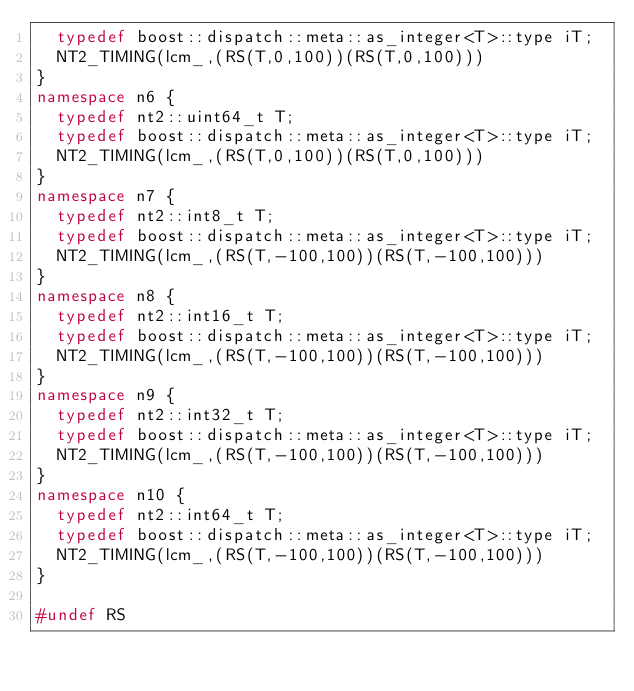<code> <loc_0><loc_0><loc_500><loc_500><_C++_>  typedef boost::dispatch::meta::as_integer<T>::type iT;
  NT2_TIMING(lcm_,(RS(T,0,100))(RS(T,0,100)))
}
namespace n6 {
  typedef nt2::uint64_t T;
  typedef boost::dispatch::meta::as_integer<T>::type iT;
  NT2_TIMING(lcm_,(RS(T,0,100))(RS(T,0,100)))
}
namespace n7 {
  typedef nt2::int8_t T;
  typedef boost::dispatch::meta::as_integer<T>::type iT;
  NT2_TIMING(lcm_,(RS(T,-100,100))(RS(T,-100,100)))
}
namespace n8 {
  typedef nt2::int16_t T;
  typedef boost::dispatch::meta::as_integer<T>::type iT;
  NT2_TIMING(lcm_,(RS(T,-100,100))(RS(T,-100,100)))
}
namespace n9 {
  typedef nt2::int32_t T;
  typedef boost::dispatch::meta::as_integer<T>::type iT;
  NT2_TIMING(lcm_,(RS(T,-100,100))(RS(T,-100,100)))
}
namespace n10 {
  typedef nt2::int64_t T;
  typedef boost::dispatch::meta::as_integer<T>::type iT;
  NT2_TIMING(lcm_,(RS(T,-100,100))(RS(T,-100,100)))
}

#undef RS
</code> 